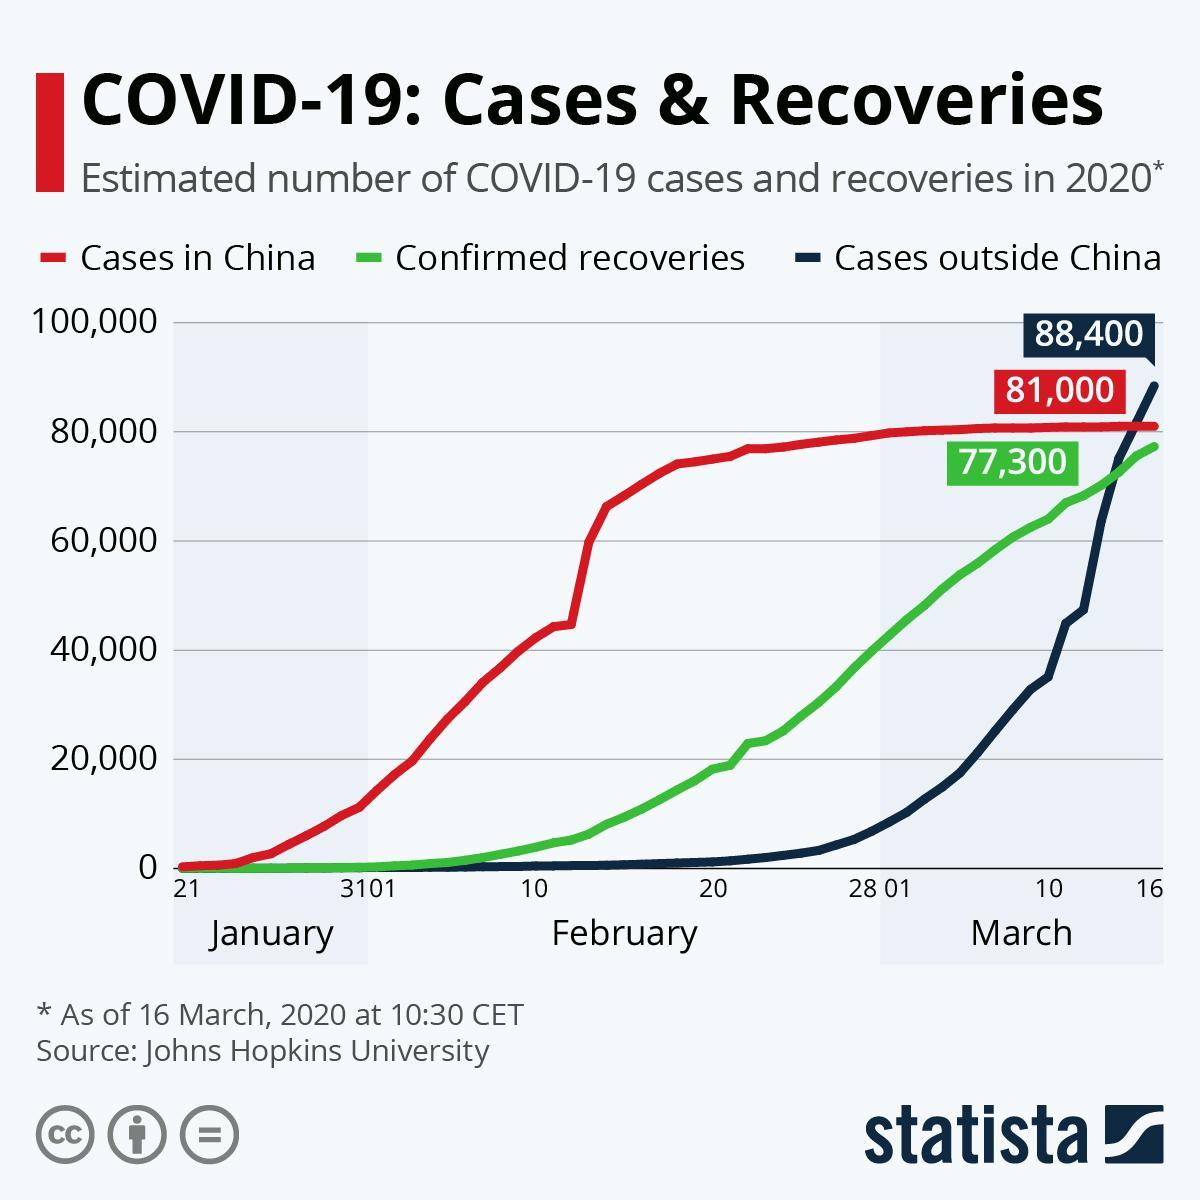What is the difference between cases in China and Confirmed recoveries?
Answer the question with a short phrase. 3,700 Which is highest- cases in China, Confirmed recoveries or cases outside china? Cases outside China 